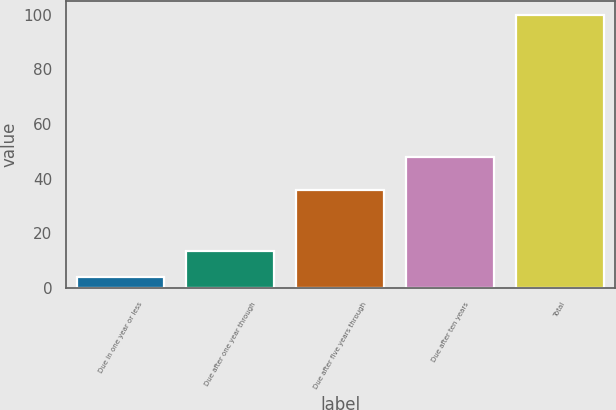Convert chart to OTSL. <chart><loc_0><loc_0><loc_500><loc_500><bar_chart><fcel>Due in one year or less<fcel>Due after one year through<fcel>Due after five years through<fcel>Due after ten years<fcel>Total<nl><fcel>4<fcel>13.6<fcel>36<fcel>48<fcel>100<nl></chart> 